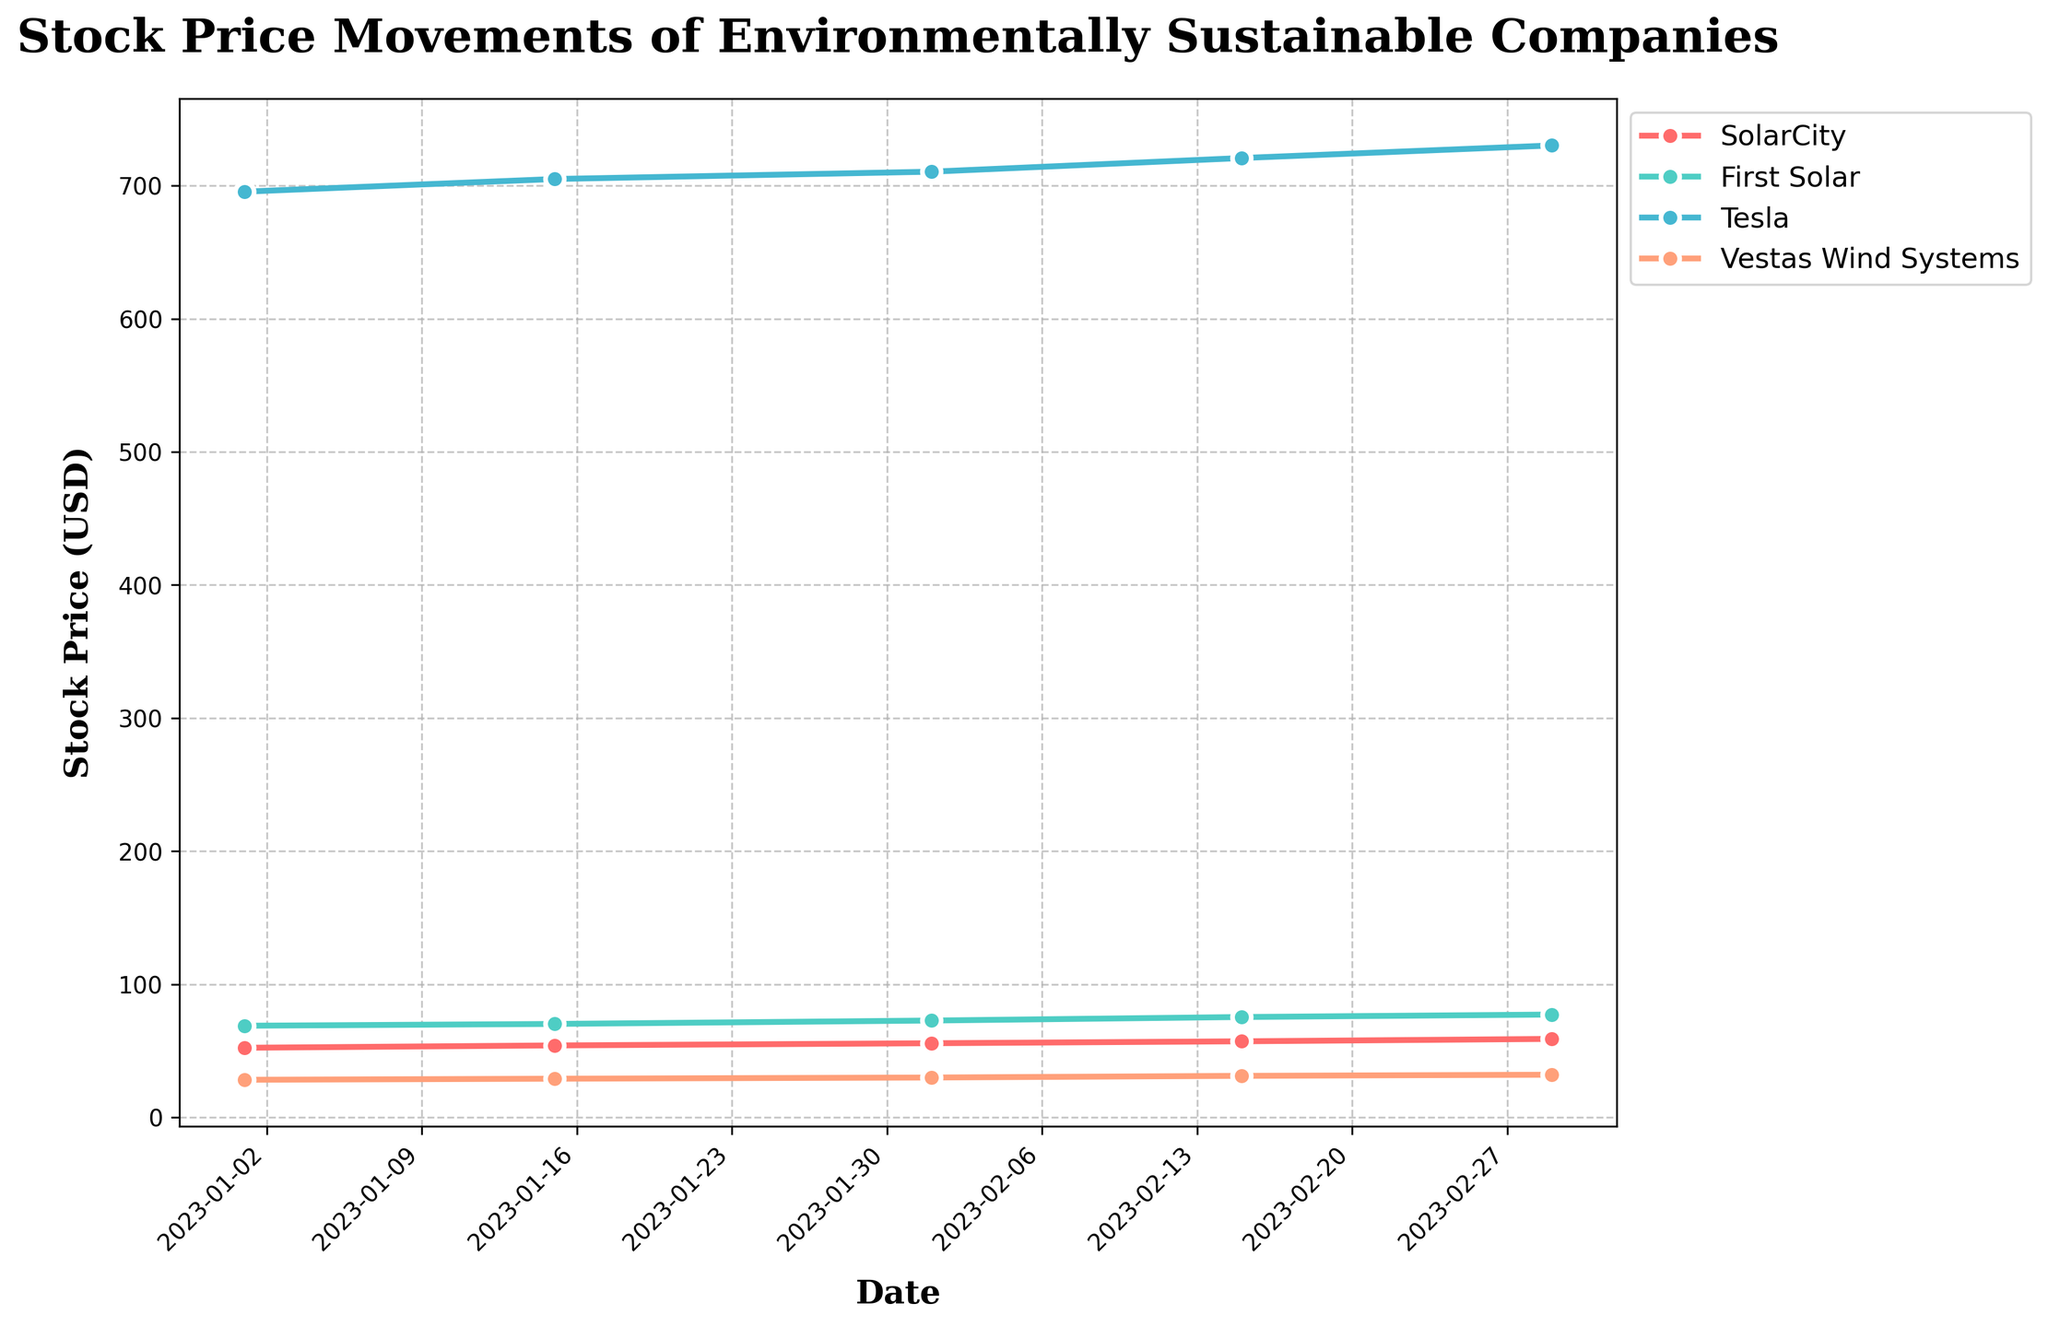What is the title of the plot? The title of the plot is usually the largest text at the top center. Here, it reads "Stock Price Movements of Environmentally Sustainable Companies".
Answer: Stock Price Movements of Environmentally Sustainable Companies What is the color used for plotting Tesla's stock price? Tesla's stock price is represented by a distinct line, and the corresponding color is a distinctive shade among the plotted lines, which is light blue.
Answer: Light blue Which company had the highest stock price on the earliest date in the dataset? To answer this, look at the stock prices for all companies on January 1, 2023. Tesla had the highest stock price, marked at 695.50 USD.
Answer: Tesla What is the overall trend for SolarCity's stock price from January to March 2023? From January 1, 2023, to March 1, 2023, one can observe that SolarCity's stock price steadily increased from 52.35 USD to 59.00 USD.
Answer: Increasing Which two companies have the closest stock prices on March 1, 2023? On March 1, 2023, compare the stock prices of all companies. SolarCity and First Solar have stock prices of 59.00 USD and 77.30 USD respectively, making them the closest in value compared to the others.
Answer: SolarCity and First Solar By how much did Vestas Wind Systems' stock price increase from January 1 to March 1, 2023? Subtract Vestas Wind Systems' stock price on January 1 (28.30 USD) from its price on March 1 (32.10 USD). The increase is 32.10 - 28.30 = 3.80 USD.
Answer: 3.80 USD What is the average stock price of First Solar over the entire period? Calculate the average by summing the stock prices of First Solar on all dates and then dividing by the number of dates. (68.90 + 70.25 + 72.80 + 75.45 + 77.30) / 5 = 72.94 USD.
Answer: 72.94 USD Did any company experience a decline in stock price within any two consecutive dates? Check the stock prices for any pair of consecutive dates for each company. None of the companies experienced a decline in their stock prices between any consecutive dates.
Answer: No Which company had the largest increase in stock price over the entire period? Compare the stock price increase for each company from January 1 to March 1. Tesla's stock price increased from 695.50 USD to 730.20 USD, the highest increase of 34.70 USD.
Answer: Tesla Which company had the smallest change in stock price from January to February 1, 2023? Calculate the change in stock price for each company from January 1, 2023, to February 1, 2023. Vestas Wind Systems had the smallest change: from 28.30 USD to 30.00 USD, which is a 1.70 USD increase.
Answer: Vestas Wind Systems 